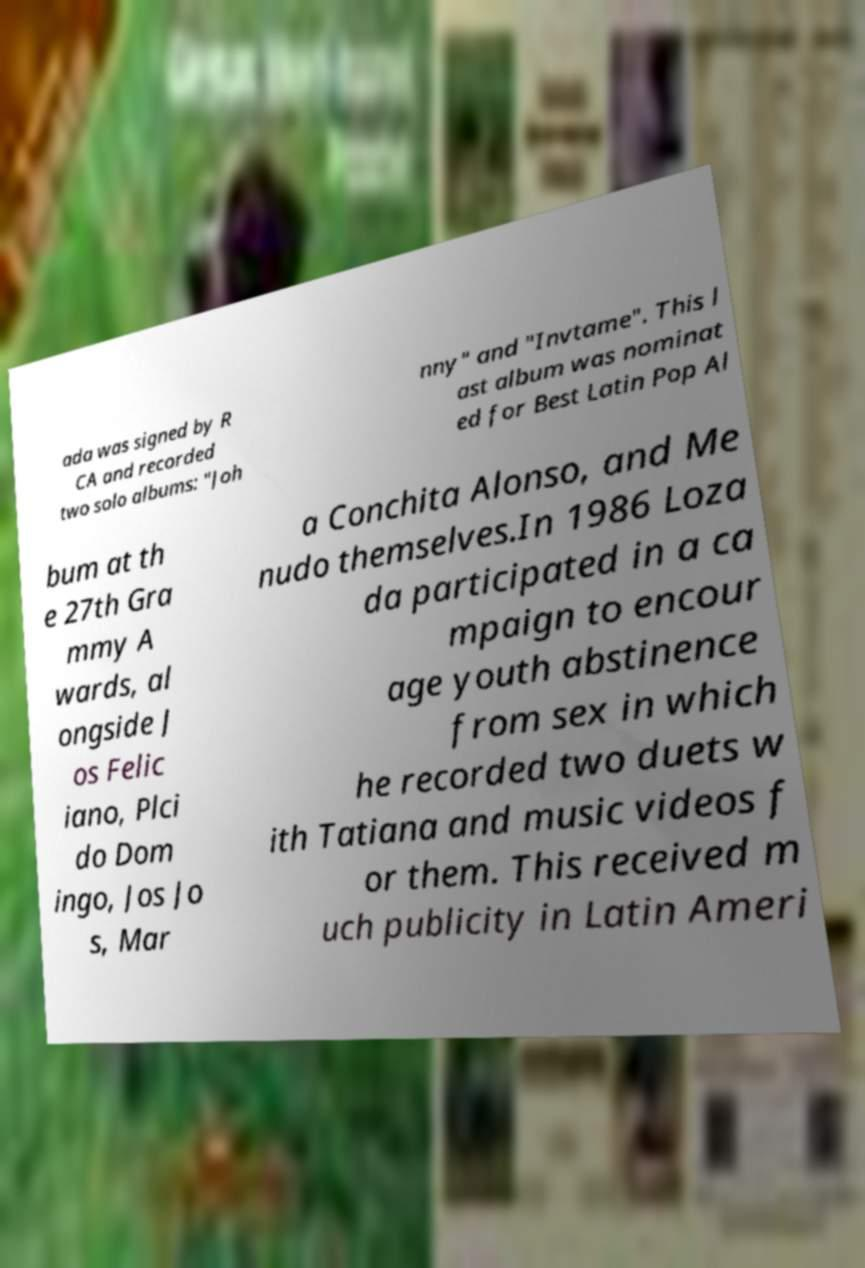What messages or text are displayed in this image? I need them in a readable, typed format. ada was signed by R CA and recorded two solo albums: "Joh nny" and "Invtame". This l ast album was nominat ed for Best Latin Pop Al bum at th e 27th Gra mmy A wards, al ongside J os Felic iano, Plci do Dom ingo, Jos Jo s, Mar a Conchita Alonso, and Me nudo themselves.In 1986 Loza da participated in a ca mpaign to encour age youth abstinence from sex in which he recorded two duets w ith Tatiana and music videos f or them. This received m uch publicity in Latin Ameri 